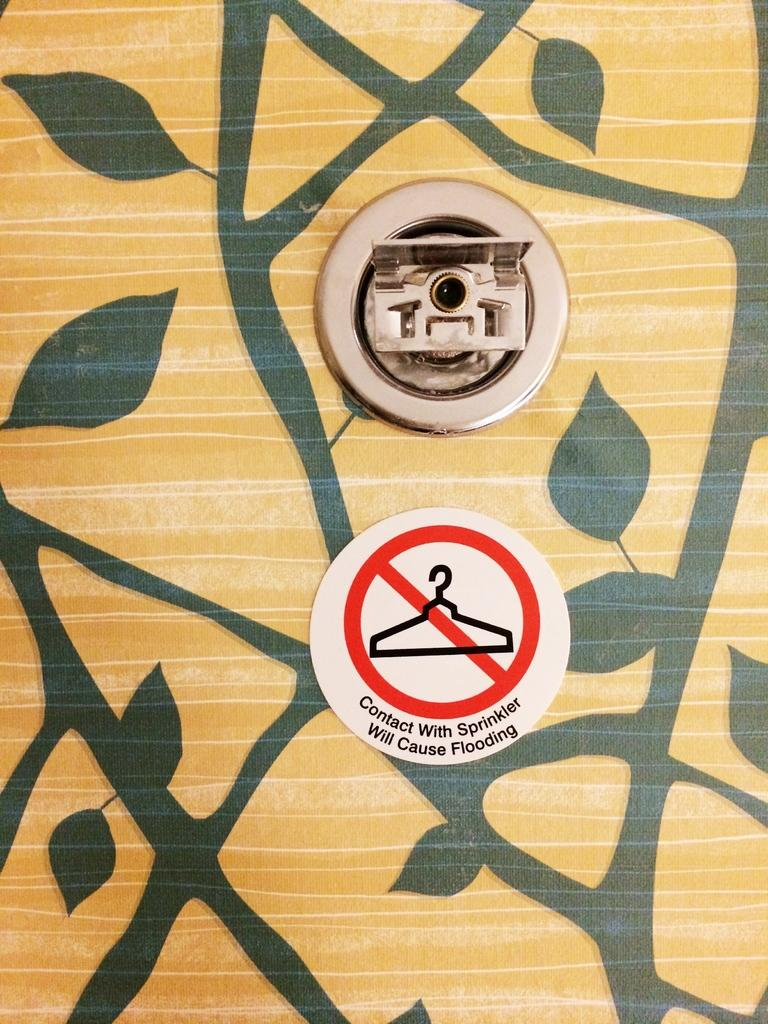What is hanging on the wall in the image? There is a painting on the wall in the image. What type of warning or instruction is present in the image? There is a caution sticker with text in the image. What safety feature can be seen in the image? There is a sprinkler in the image. What type of punishment is depicted in the painting in the image? There is no punishment depicted in the painting in the image, as the facts provided do not mention any specific content within the painting. 